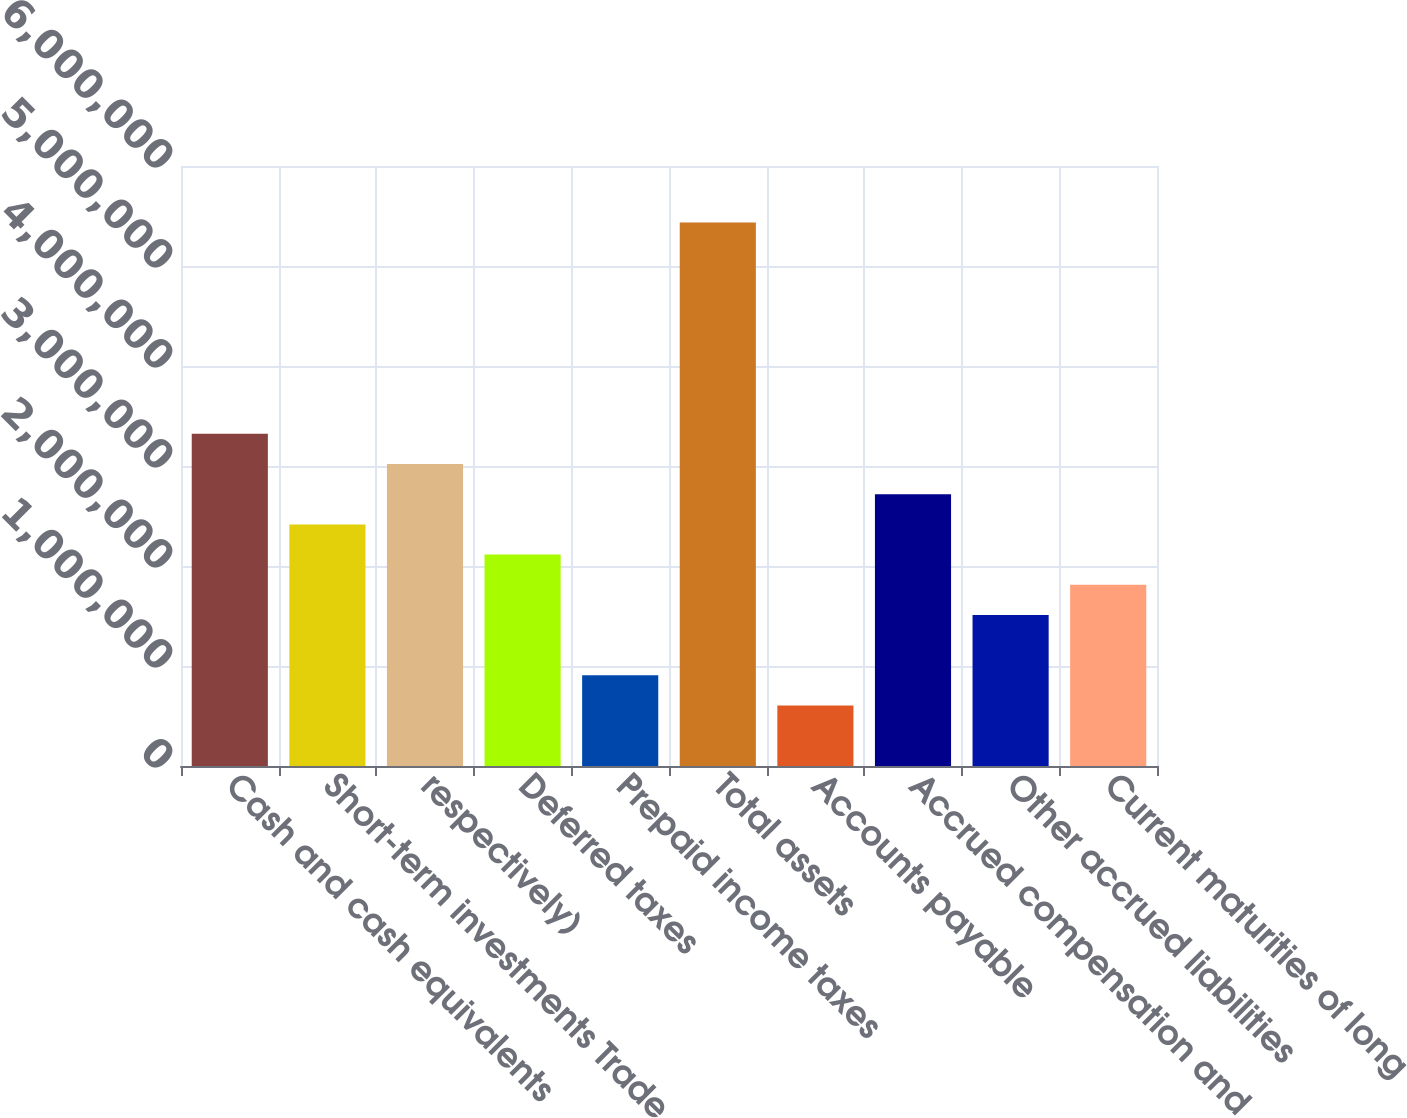Convert chart. <chart><loc_0><loc_0><loc_500><loc_500><bar_chart><fcel>Cash and cash equivalents<fcel>Short-term investments Trade<fcel>respectively)<fcel>Deferred taxes<fcel>Prepaid income taxes<fcel>Total assets<fcel>Accounts payable<fcel>Accrued compensation and<fcel>Other accrued liabilities<fcel>Current maturities of long<nl><fcel>3.32148e+06<fcel>2.41596e+06<fcel>3.01964e+06<fcel>2.11412e+06<fcel>906760<fcel>5.43436e+06<fcel>604920<fcel>2.7178e+06<fcel>1.51044e+06<fcel>1.81228e+06<nl></chart> 